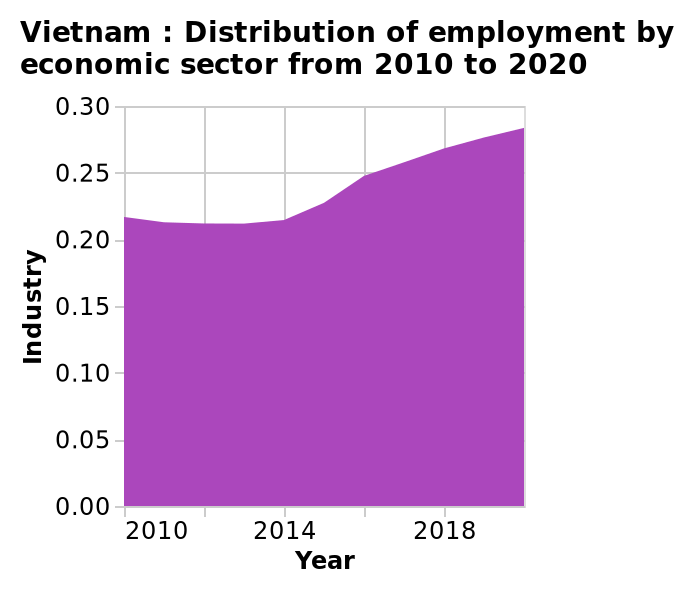<image>
What are the economic sectors represented in the area diagram? The economic sectors represented in the area diagram are not stated in the given description. 